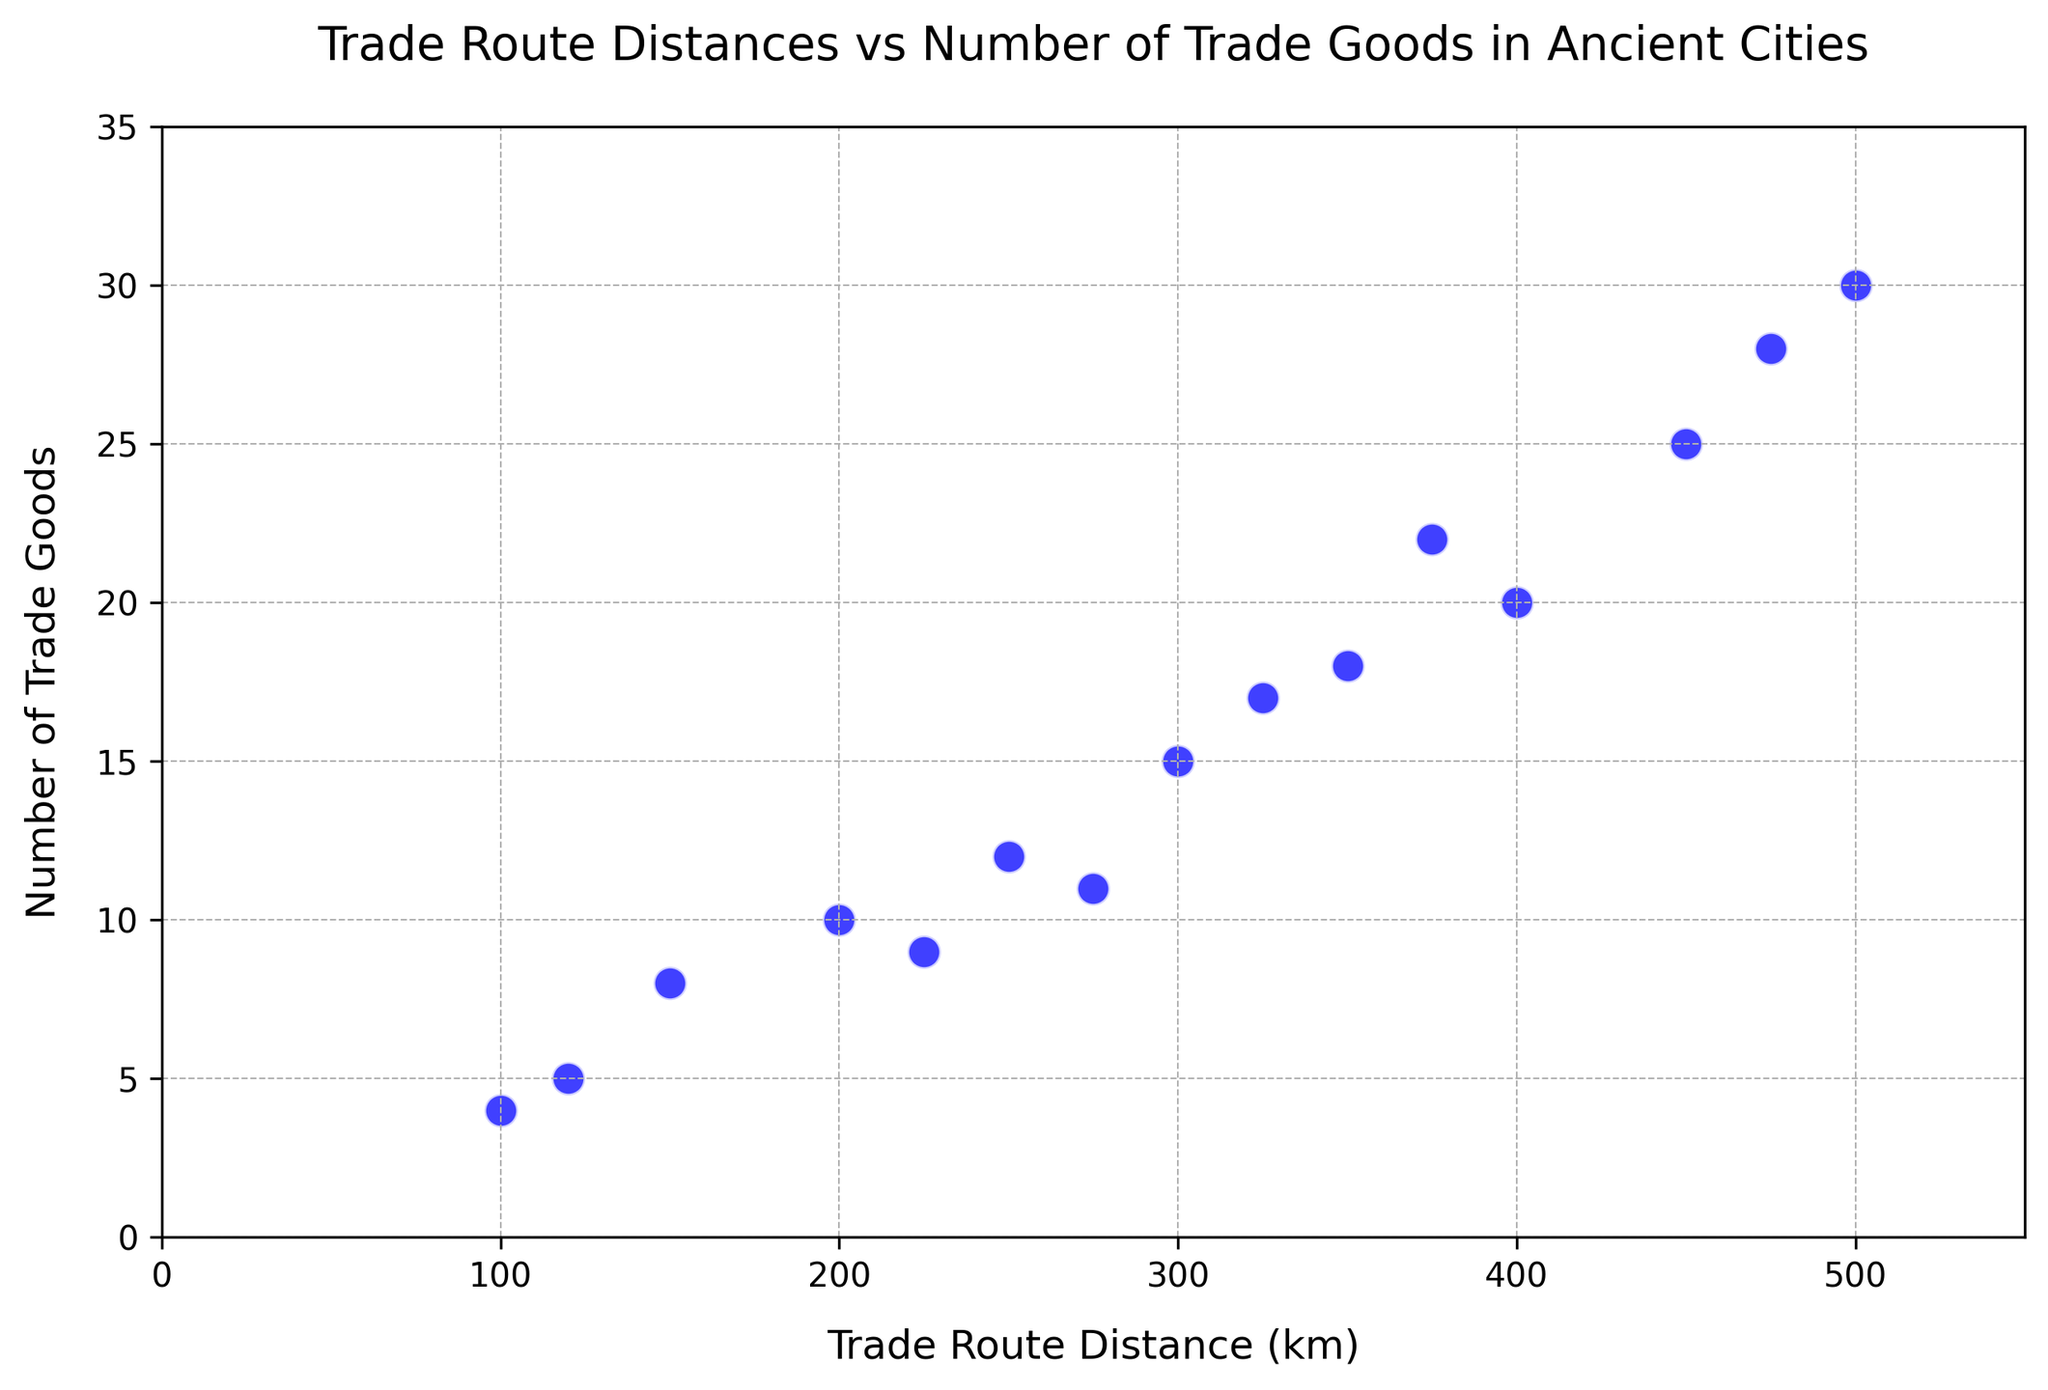What is the maximum number of trade goods recorded in the figure? Locate the highest data point on the y-axis labeled 'Number of Trade Goods.' From the figure, the highest y-value is 30.
Answer: 30 Which trade route distance corresponds to the lowest number of trade goods? Identify the lowest data point on the y-axis, which represents the 'Number of Trade Goods.' This point aligns with 100 km on the x-axis.
Answer: 100 km How does the number of trade goods change as the trade route distance increases for the majority of the data points? By observing the trend in the scatter plot, most points show an increase in the number of trade goods as the trade route distance increases.
Answer: The number of trade goods increases What is the average number of trade goods for trade routes with distances greater than 300 km? Identify the data points with trade route distances > 300 km (350, 325, 375, 450, 400, 475, 500). Sum their y-values (18+17+22+25+20+28+30) and divide by 7 (number of such points). The average is approximately 22.86.
Answer: 22.86 Compare the number of trade goods for the shortest and the longest trade routes shown in the plot. The shortest trade route (100 km) has 4 trade goods, while the longest trade route (500 km) has 30 trade goods. By comparing their y-values, the longest route has a higher number of trade goods.
Answer: The longest route has more What is the range of trade route distances represented in the figure? Identify the smallest and largest x-values on the scatter plot, which are 100 km and 500 km, respectively. Subtract the smallest value from the largest: 500 - 100 = 400 km.
Answer: 400 km Determine the trade route distance range that contains the highest number of trade goods. Observe the cluster of points with the highest y-values. The distance range of 450 km to 500 km contains data points with y-values of 25, 28, and 30.
Answer: 450 km to 500 km What is the total number of trade goods traded for trade routes of 300 km and 500 km? Identify data points for distances of 300 km and 500 km (y-values are 15 and 30, respectively). Add the y-values: 15+30 = 45.
Answer: 45 What trend can be observed in the relationship between trade route distance and number of trade goods in the scatter plot? By examining the overall distribution, an upward trend is apparent—longer distances generally correlate with more trade goods.
Answer: Positive correlation Which trade route distance has a higher variability in the number of trade goods: 200 km or 400 km? By observing the scatter plot, notice that 200 km shows a range from 9 to 12, while 400 km shows fewer points at 20. Variability is higher for 200 km compared to 400 km.
Answer: 200 km 